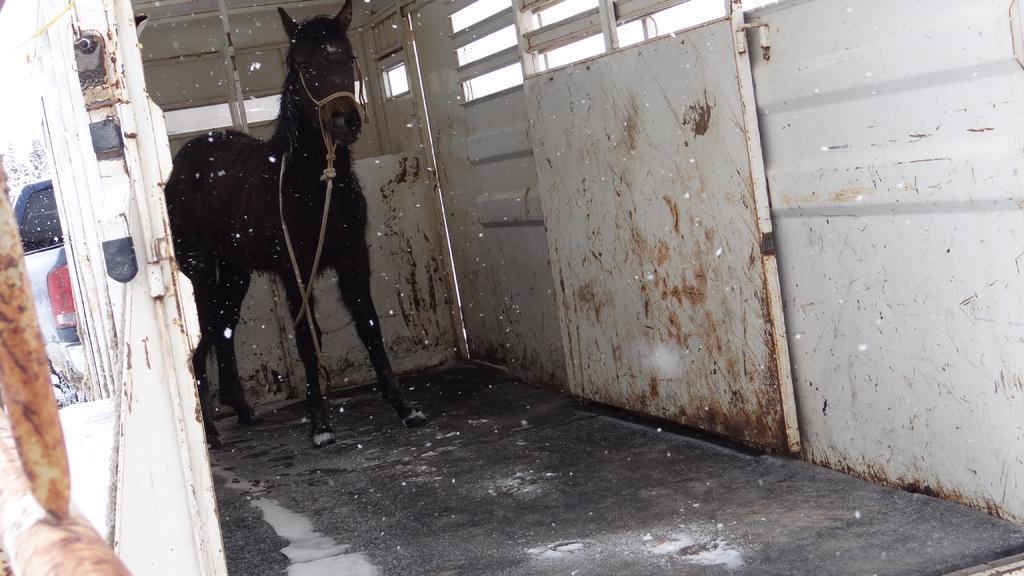Could you give a brief overview of what you see in this image? In this image we can see a horse tied with rope. On the right side there is a wall with a door. In the back there is a vehicle. 